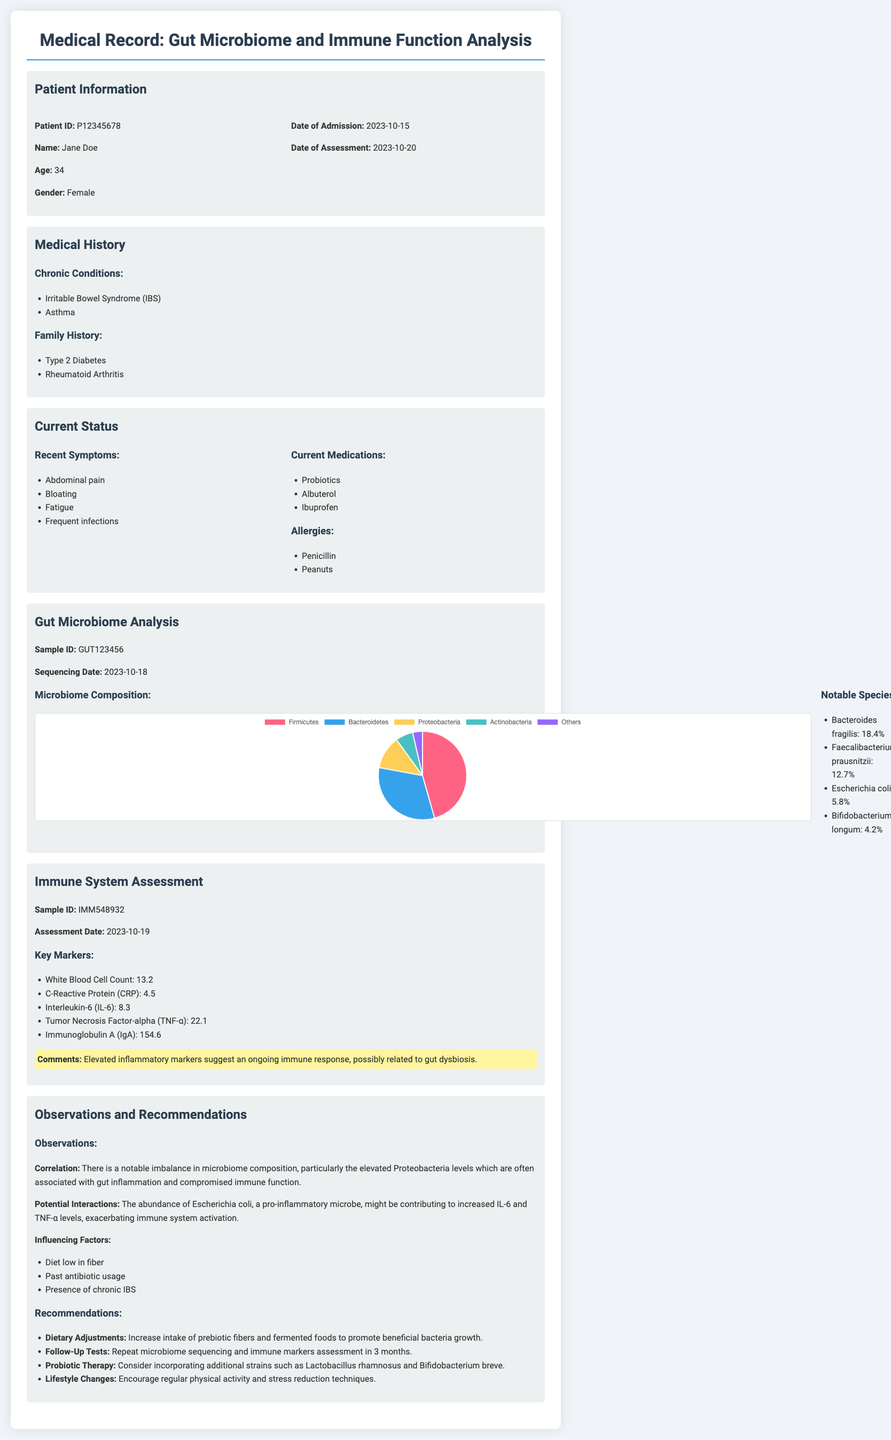What is the patient's name? The patient's name is listed in the Patient Information section of the document.
Answer: Jane Doe What is the patient's age? The patient's age is mentioned in the Patient Information section.
Answer: 34 When was the immune system assessment conducted? The assessment date for the immune system is provided in the document.
Answer: 2023-10-19 What notable species is present at 12.7% in the microbiome composition? This percentage is given in the Gut Microbiome Analysis section, listing notable species.
Answer: Faecalibacterium prausnitzii What is the White Blood Cell Count? The count is part of the key markers in the Immune System Assessment section.
Answer: 13.2 What dietary adjustment is recommended? The suggestions for dietary changes are listed in the Observations and Recommendations section.
Answer: Increase intake of prebiotic fibers What chronic condition does the patient have? The medical history includes chronic conditions noted in the appropriate section.
Answer: Irritable Bowel Syndrome (IBS) What is the significance of the elevated inflammatory markers? The comments regarding these markers are found in the Immune System Assessment.
Answer: Ongoing immune response How many days passed between the admission and the immune assessment? The dates of admission and assessment can be used to calculate the interval between them.
Answer: 4 days 